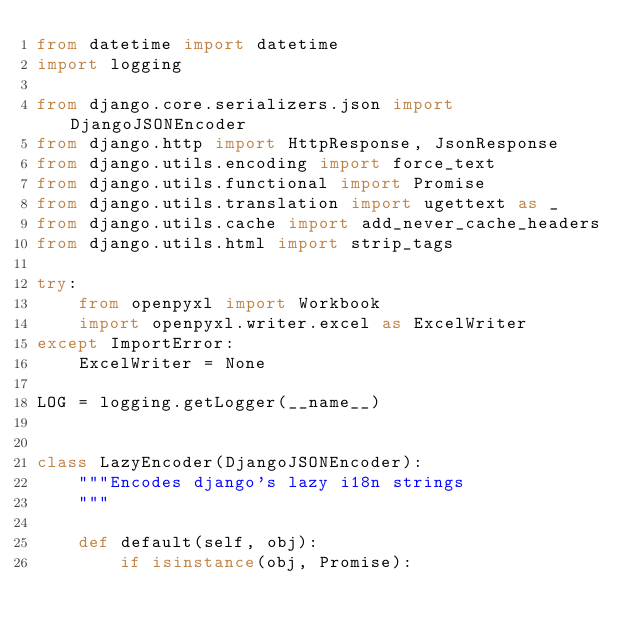<code> <loc_0><loc_0><loc_500><loc_500><_Python_>from datetime import datetime
import logging

from django.core.serializers.json import DjangoJSONEncoder
from django.http import HttpResponse, JsonResponse
from django.utils.encoding import force_text
from django.utils.functional import Promise
from django.utils.translation import ugettext as _
from django.utils.cache import add_never_cache_headers
from django.utils.html import strip_tags

try:
    from openpyxl import Workbook
    import openpyxl.writer.excel as ExcelWriter
except ImportError:
    ExcelWriter = None

LOG = logging.getLogger(__name__)


class LazyEncoder(DjangoJSONEncoder):
    """Encodes django's lazy i18n strings
    """

    def default(self, obj):
        if isinstance(obj, Promise):</code> 